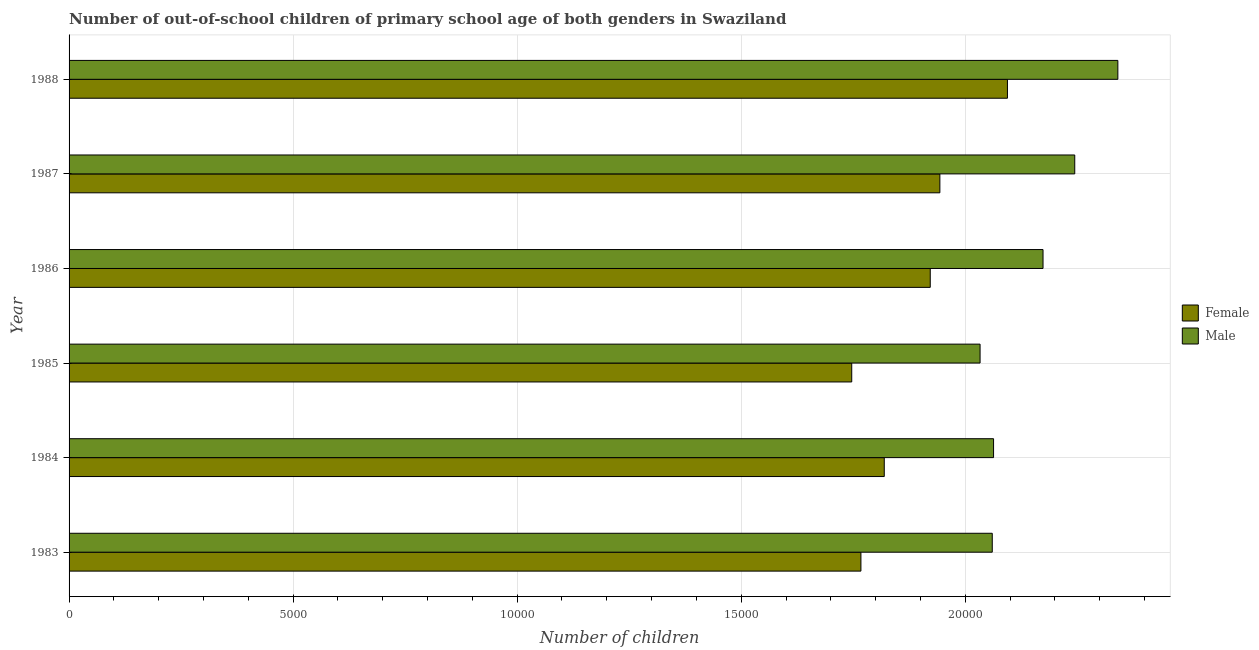Are the number of bars per tick equal to the number of legend labels?
Provide a short and direct response. Yes. Are the number of bars on each tick of the Y-axis equal?
Keep it short and to the point. Yes. How many bars are there on the 3rd tick from the top?
Offer a terse response. 2. How many bars are there on the 1st tick from the bottom?
Your answer should be very brief. 2. What is the label of the 2nd group of bars from the top?
Provide a succinct answer. 1987. What is the number of male out-of-school students in 1985?
Your response must be concise. 2.03e+04. Across all years, what is the maximum number of female out-of-school students?
Your response must be concise. 2.09e+04. Across all years, what is the minimum number of female out-of-school students?
Your answer should be very brief. 1.75e+04. In which year was the number of female out-of-school students maximum?
Ensure brevity in your answer.  1988. In which year was the number of male out-of-school students minimum?
Make the answer very short. 1985. What is the total number of female out-of-school students in the graph?
Provide a short and direct response. 1.13e+05. What is the difference between the number of male out-of-school students in 1987 and that in 1988?
Give a very brief answer. -962. What is the difference between the number of female out-of-school students in 1988 and the number of male out-of-school students in 1983?
Provide a succinct answer. 339. What is the average number of female out-of-school students per year?
Offer a very short reply. 1.88e+04. In the year 1987, what is the difference between the number of male out-of-school students and number of female out-of-school students?
Your answer should be compact. 3010. What is the ratio of the number of female out-of-school students in 1987 to that in 1988?
Ensure brevity in your answer.  0.93. Is the number of male out-of-school students in 1983 less than that in 1988?
Your answer should be very brief. Yes. What is the difference between the highest and the second highest number of male out-of-school students?
Keep it short and to the point. 962. What is the difference between the highest and the lowest number of female out-of-school students?
Give a very brief answer. 3475. How many bars are there?
Offer a terse response. 12. Are the values on the major ticks of X-axis written in scientific E-notation?
Your response must be concise. No. Does the graph contain any zero values?
Your answer should be compact. No. Does the graph contain grids?
Keep it short and to the point. Yes. Where does the legend appear in the graph?
Give a very brief answer. Center right. How are the legend labels stacked?
Your response must be concise. Vertical. What is the title of the graph?
Ensure brevity in your answer.  Number of out-of-school children of primary school age of both genders in Swaziland. Does "IMF nonconcessional" appear as one of the legend labels in the graph?
Offer a very short reply. No. What is the label or title of the X-axis?
Provide a succinct answer. Number of children. What is the label or title of the Y-axis?
Make the answer very short. Year. What is the Number of children of Female in 1983?
Ensure brevity in your answer.  1.77e+04. What is the Number of children of Male in 1983?
Your response must be concise. 2.06e+04. What is the Number of children of Female in 1984?
Give a very brief answer. 1.82e+04. What is the Number of children of Male in 1984?
Your response must be concise. 2.06e+04. What is the Number of children of Female in 1985?
Your answer should be compact. 1.75e+04. What is the Number of children in Male in 1985?
Provide a short and direct response. 2.03e+04. What is the Number of children of Female in 1986?
Provide a short and direct response. 1.92e+04. What is the Number of children in Male in 1986?
Your response must be concise. 2.17e+04. What is the Number of children of Female in 1987?
Keep it short and to the point. 1.94e+04. What is the Number of children of Male in 1987?
Ensure brevity in your answer.  2.24e+04. What is the Number of children in Female in 1988?
Your response must be concise. 2.09e+04. What is the Number of children of Male in 1988?
Keep it short and to the point. 2.34e+04. Across all years, what is the maximum Number of children of Female?
Your answer should be compact. 2.09e+04. Across all years, what is the maximum Number of children in Male?
Give a very brief answer. 2.34e+04. Across all years, what is the minimum Number of children in Female?
Keep it short and to the point. 1.75e+04. Across all years, what is the minimum Number of children in Male?
Your answer should be compact. 2.03e+04. What is the total Number of children of Female in the graph?
Your answer should be compact. 1.13e+05. What is the total Number of children in Male in the graph?
Make the answer very short. 1.29e+05. What is the difference between the Number of children of Female in 1983 and that in 1984?
Provide a succinct answer. -521. What is the difference between the Number of children of Female in 1983 and that in 1985?
Ensure brevity in your answer.  205. What is the difference between the Number of children of Male in 1983 and that in 1985?
Provide a succinct answer. 272. What is the difference between the Number of children in Female in 1983 and that in 1986?
Provide a short and direct response. -1547. What is the difference between the Number of children in Male in 1983 and that in 1986?
Provide a succinct answer. -1133. What is the difference between the Number of children of Female in 1983 and that in 1987?
Your response must be concise. -1762. What is the difference between the Number of children in Male in 1983 and that in 1987?
Ensure brevity in your answer.  -1841. What is the difference between the Number of children in Female in 1983 and that in 1988?
Your answer should be very brief. -3270. What is the difference between the Number of children of Male in 1983 and that in 1988?
Provide a succinct answer. -2803. What is the difference between the Number of children in Female in 1984 and that in 1985?
Provide a succinct answer. 726. What is the difference between the Number of children in Male in 1984 and that in 1985?
Make the answer very short. 301. What is the difference between the Number of children in Female in 1984 and that in 1986?
Ensure brevity in your answer.  -1026. What is the difference between the Number of children of Male in 1984 and that in 1986?
Keep it short and to the point. -1104. What is the difference between the Number of children in Female in 1984 and that in 1987?
Your answer should be very brief. -1241. What is the difference between the Number of children in Male in 1984 and that in 1987?
Your answer should be very brief. -1812. What is the difference between the Number of children in Female in 1984 and that in 1988?
Your answer should be compact. -2749. What is the difference between the Number of children in Male in 1984 and that in 1988?
Make the answer very short. -2774. What is the difference between the Number of children of Female in 1985 and that in 1986?
Provide a succinct answer. -1752. What is the difference between the Number of children of Male in 1985 and that in 1986?
Offer a terse response. -1405. What is the difference between the Number of children in Female in 1985 and that in 1987?
Keep it short and to the point. -1967. What is the difference between the Number of children in Male in 1985 and that in 1987?
Your response must be concise. -2113. What is the difference between the Number of children in Female in 1985 and that in 1988?
Your response must be concise. -3475. What is the difference between the Number of children of Male in 1985 and that in 1988?
Provide a short and direct response. -3075. What is the difference between the Number of children of Female in 1986 and that in 1987?
Offer a terse response. -215. What is the difference between the Number of children of Male in 1986 and that in 1987?
Keep it short and to the point. -708. What is the difference between the Number of children of Female in 1986 and that in 1988?
Offer a very short reply. -1723. What is the difference between the Number of children of Male in 1986 and that in 1988?
Make the answer very short. -1670. What is the difference between the Number of children in Female in 1987 and that in 1988?
Offer a very short reply. -1508. What is the difference between the Number of children in Male in 1987 and that in 1988?
Offer a terse response. -962. What is the difference between the Number of children in Female in 1983 and the Number of children in Male in 1984?
Give a very brief answer. -2960. What is the difference between the Number of children in Female in 1983 and the Number of children in Male in 1985?
Your response must be concise. -2659. What is the difference between the Number of children in Female in 1983 and the Number of children in Male in 1986?
Keep it short and to the point. -4064. What is the difference between the Number of children in Female in 1983 and the Number of children in Male in 1987?
Keep it short and to the point. -4772. What is the difference between the Number of children in Female in 1983 and the Number of children in Male in 1988?
Your answer should be very brief. -5734. What is the difference between the Number of children of Female in 1984 and the Number of children of Male in 1985?
Offer a very short reply. -2138. What is the difference between the Number of children of Female in 1984 and the Number of children of Male in 1986?
Keep it short and to the point. -3543. What is the difference between the Number of children of Female in 1984 and the Number of children of Male in 1987?
Offer a very short reply. -4251. What is the difference between the Number of children in Female in 1984 and the Number of children in Male in 1988?
Provide a succinct answer. -5213. What is the difference between the Number of children in Female in 1985 and the Number of children in Male in 1986?
Provide a short and direct response. -4269. What is the difference between the Number of children of Female in 1985 and the Number of children of Male in 1987?
Your answer should be compact. -4977. What is the difference between the Number of children in Female in 1985 and the Number of children in Male in 1988?
Offer a terse response. -5939. What is the difference between the Number of children in Female in 1986 and the Number of children in Male in 1987?
Give a very brief answer. -3225. What is the difference between the Number of children of Female in 1986 and the Number of children of Male in 1988?
Provide a short and direct response. -4187. What is the difference between the Number of children in Female in 1987 and the Number of children in Male in 1988?
Your answer should be compact. -3972. What is the average Number of children of Female per year?
Your response must be concise. 1.88e+04. What is the average Number of children of Male per year?
Provide a succinct answer. 2.15e+04. In the year 1983, what is the difference between the Number of children of Female and Number of children of Male?
Give a very brief answer. -2931. In the year 1984, what is the difference between the Number of children in Female and Number of children in Male?
Ensure brevity in your answer.  -2439. In the year 1985, what is the difference between the Number of children of Female and Number of children of Male?
Your answer should be very brief. -2864. In the year 1986, what is the difference between the Number of children in Female and Number of children in Male?
Provide a succinct answer. -2517. In the year 1987, what is the difference between the Number of children of Female and Number of children of Male?
Make the answer very short. -3010. In the year 1988, what is the difference between the Number of children in Female and Number of children in Male?
Offer a very short reply. -2464. What is the ratio of the Number of children in Female in 1983 to that in 1984?
Give a very brief answer. 0.97. What is the ratio of the Number of children of Male in 1983 to that in 1984?
Make the answer very short. 1. What is the ratio of the Number of children of Female in 1983 to that in 1985?
Give a very brief answer. 1.01. What is the ratio of the Number of children of Male in 1983 to that in 1985?
Make the answer very short. 1.01. What is the ratio of the Number of children of Female in 1983 to that in 1986?
Your answer should be very brief. 0.92. What is the ratio of the Number of children of Male in 1983 to that in 1986?
Provide a short and direct response. 0.95. What is the ratio of the Number of children of Female in 1983 to that in 1987?
Ensure brevity in your answer.  0.91. What is the ratio of the Number of children in Male in 1983 to that in 1987?
Provide a succinct answer. 0.92. What is the ratio of the Number of children in Female in 1983 to that in 1988?
Your answer should be very brief. 0.84. What is the ratio of the Number of children in Male in 1983 to that in 1988?
Make the answer very short. 0.88. What is the ratio of the Number of children of Female in 1984 to that in 1985?
Offer a terse response. 1.04. What is the ratio of the Number of children of Male in 1984 to that in 1985?
Offer a terse response. 1.01. What is the ratio of the Number of children in Female in 1984 to that in 1986?
Keep it short and to the point. 0.95. What is the ratio of the Number of children in Male in 1984 to that in 1986?
Ensure brevity in your answer.  0.95. What is the ratio of the Number of children in Female in 1984 to that in 1987?
Give a very brief answer. 0.94. What is the ratio of the Number of children in Male in 1984 to that in 1987?
Your response must be concise. 0.92. What is the ratio of the Number of children in Female in 1984 to that in 1988?
Offer a terse response. 0.87. What is the ratio of the Number of children in Male in 1984 to that in 1988?
Make the answer very short. 0.88. What is the ratio of the Number of children of Female in 1985 to that in 1986?
Offer a terse response. 0.91. What is the ratio of the Number of children of Male in 1985 to that in 1986?
Your response must be concise. 0.94. What is the ratio of the Number of children in Female in 1985 to that in 1987?
Ensure brevity in your answer.  0.9. What is the ratio of the Number of children of Male in 1985 to that in 1987?
Provide a short and direct response. 0.91. What is the ratio of the Number of children in Female in 1985 to that in 1988?
Make the answer very short. 0.83. What is the ratio of the Number of children in Male in 1985 to that in 1988?
Keep it short and to the point. 0.87. What is the ratio of the Number of children in Female in 1986 to that in 1987?
Your answer should be very brief. 0.99. What is the ratio of the Number of children in Male in 1986 to that in 1987?
Your answer should be compact. 0.97. What is the ratio of the Number of children in Female in 1986 to that in 1988?
Offer a very short reply. 0.92. What is the ratio of the Number of children of Female in 1987 to that in 1988?
Your response must be concise. 0.93. What is the ratio of the Number of children of Male in 1987 to that in 1988?
Offer a very short reply. 0.96. What is the difference between the highest and the second highest Number of children of Female?
Keep it short and to the point. 1508. What is the difference between the highest and the second highest Number of children in Male?
Offer a very short reply. 962. What is the difference between the highest and the lowest Number of children of Female?
Your response must be concise. 3475. What is the difference between the highest and the lowest Number of children of Male?
Your answer should be very brief. 3075. 